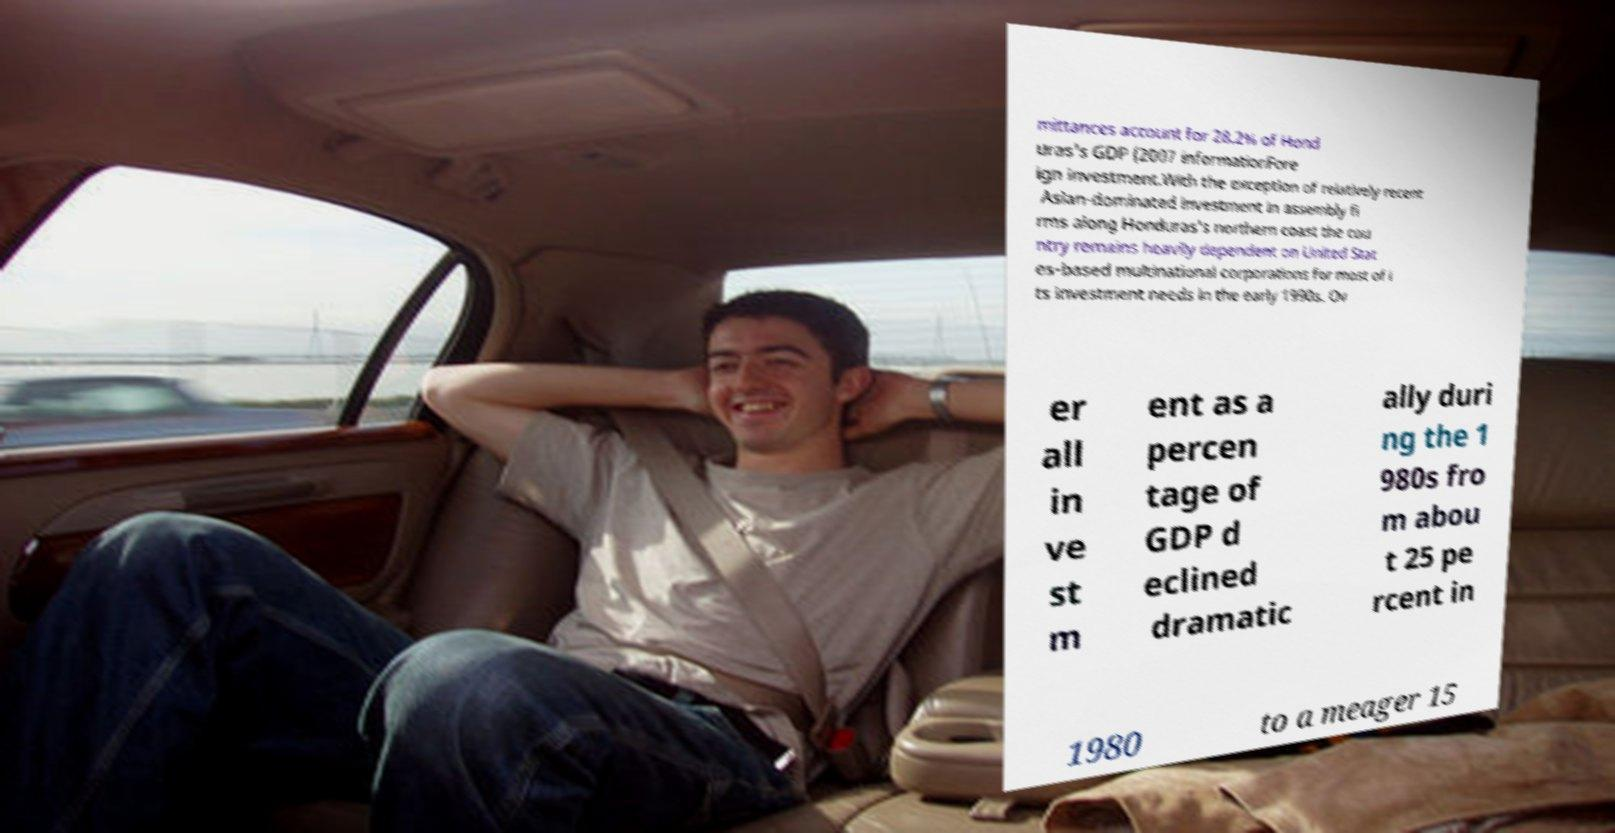Could you assist in decoding the text presented in this image and type it out clearly? mittances account for 28.2% of Hond uras's GDP (2007 informationFore ign investment.With the exception of relatively recent Asian-dominated investment in assembly fi rms along Honduras's northern coast the cou ntry remains heavily dependent on United Stat es-based multinational corporations for most of i ts investment needs in the early 1990s. Ov er all in ve st m ent as a percen tage of GDP d eclined dramatic ally duri ng the 1 980s fro m abou t 25 pe rcent in 1980 to a meager 15 